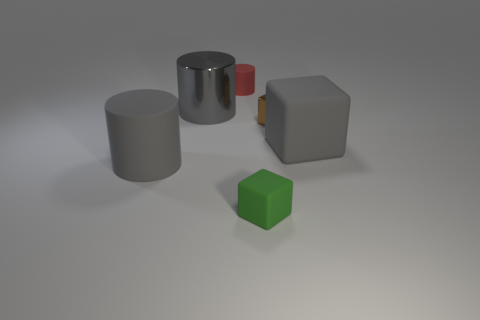Subtract all small green rubber cubes. How many cubes are left? 2 Add 3 small red cylinders. How many objects exist? 9 Subtract 2 blocks. How many blocks are left? 1 Add 2 red matte blocks. How many red matte blocks exist? 2 Subtract all red cylinders. How many cylinders are left? 2 Subtract 0 purple cubes. How many objects are left? 6 Subtract all gray cubes. Subtract all cyan cylinders. How many cubes are left? 2 Subtract all blue cubes. How many gray cylinders are left? 2 Subtract all tiny purple metallic things. Subtract all large matte cylinders. How many objects are left? 5 Add 6 metallic cylinders. How many metallic cylinders are left? 7 